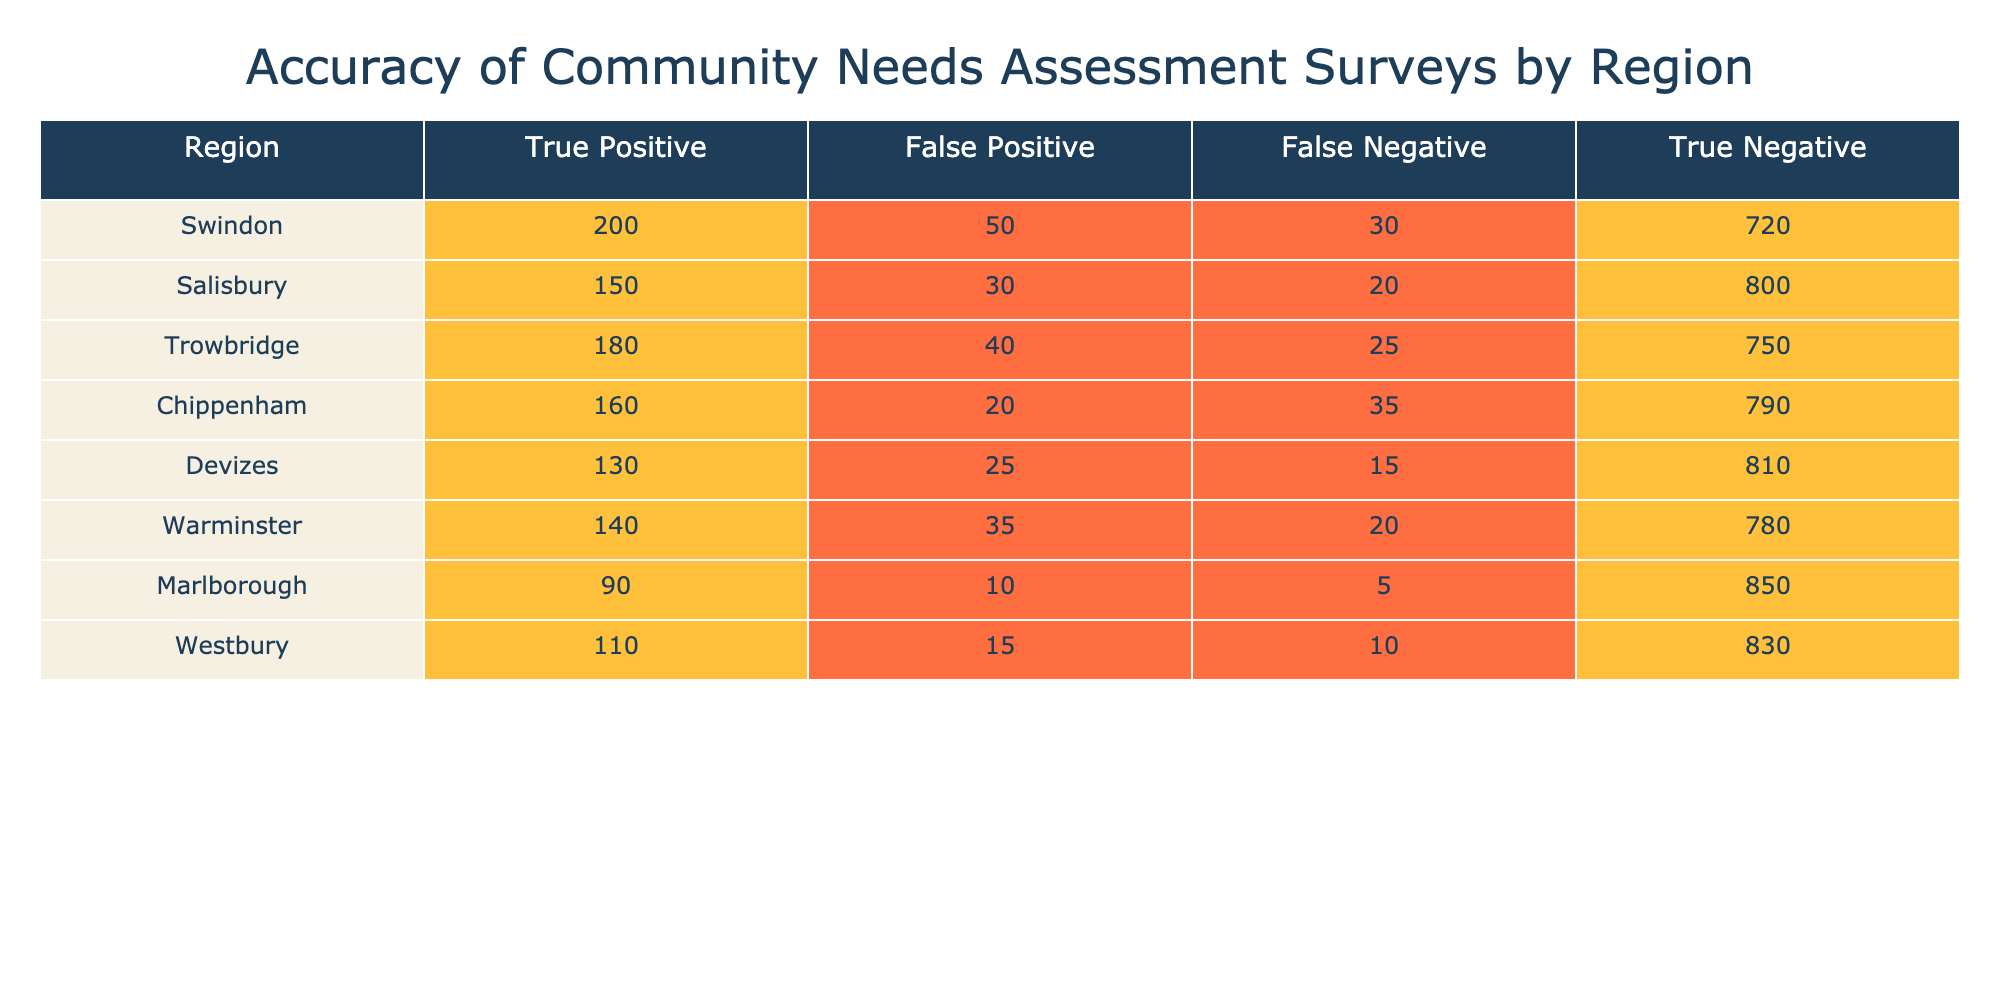What is the True Positive count for Salisbury? The True Positive for Salisbury is directly listed in the table under the corresponding region. It shows that the count is 150.
Answer: 150 Which region has the highest True Negative count? By examining the True Negative column, we see the values for each region: Swindon has 720, Salisbury has 800, Trowbridge has 750, Chippenham has 790, Devizes has 810, Warminster has 780, Marlborough has 850, and Westbury has 830. The highest value is for Marlborough with 850.
Answer: Marlborough What is the sum of False Positives for all regions? To find the sum of False Positives, we add the values from the False Positive column: 50 (Swindon) + 30 (Salisbury) + 40 (Trowbridge) + 20 (Chippenham) + 25 (Devizes) + 35 (Warminster) + 10 (Marlborough) + 15 (Westbury) = 225.
Answer: 225 Is the True Positive count for Trowbridge greater than that for Chippenham? The True Positive for Trowbridge is 180, while for Chippenham, it is 160. Since 180 is greater than 160, the statement is true.
Answer: Yes What is the average number of False Negatives across all regions? First, we find the False Negative counts: 30 (Swindon), 20 (Salisbury), 25 (Trowbridge), 35 (Chippenham), 15 (Devizes), 20 (Warminster), 5 (Marlborough), and 10 (Westbury). Adding these gives 30 + 20 + 25 + 35 + 15 + 20 + 5 + 10 = 155. There are 8 regions, so we divide the total by 8: 155/8 = 19.375.
Answer: 19.375 Which region has the second highest number of True Positives? The True Positive counts are: 200 (Swindon), 150 (Salisbury), 180 (Trowbridge), 160 (Chippenham), 130 (Devizes), 140 (Warminster), 90 (Marlborough), and 110 (Westbury). Arranging them in descending order, we see that Swindon has the highest and Trowbridge has the second highest.
Answer: Trowbridge If we combine the True Negatives from Devizes and Marlborough, what is the total? The True Negative for Devizes is 810 and for Marlborough it is 850. We sum these values: 810 + 850 = 1660.
Answer: 1660 Does Warminster have a higher count of False Negatives than Trowbridge? Warminster shows a False Negative count of 20, and Trowbridge has 25. Since 20 is not greater than 25, the statement is false.
Answer: No What is the difference in True Positives between the region with the highest count and the region with the lowest count? The highest True Positive is 200 (Swindon) and the lowest is 90 (Marlborough). The difference is therefore 200 - 90 = 110.
Answer: 110 